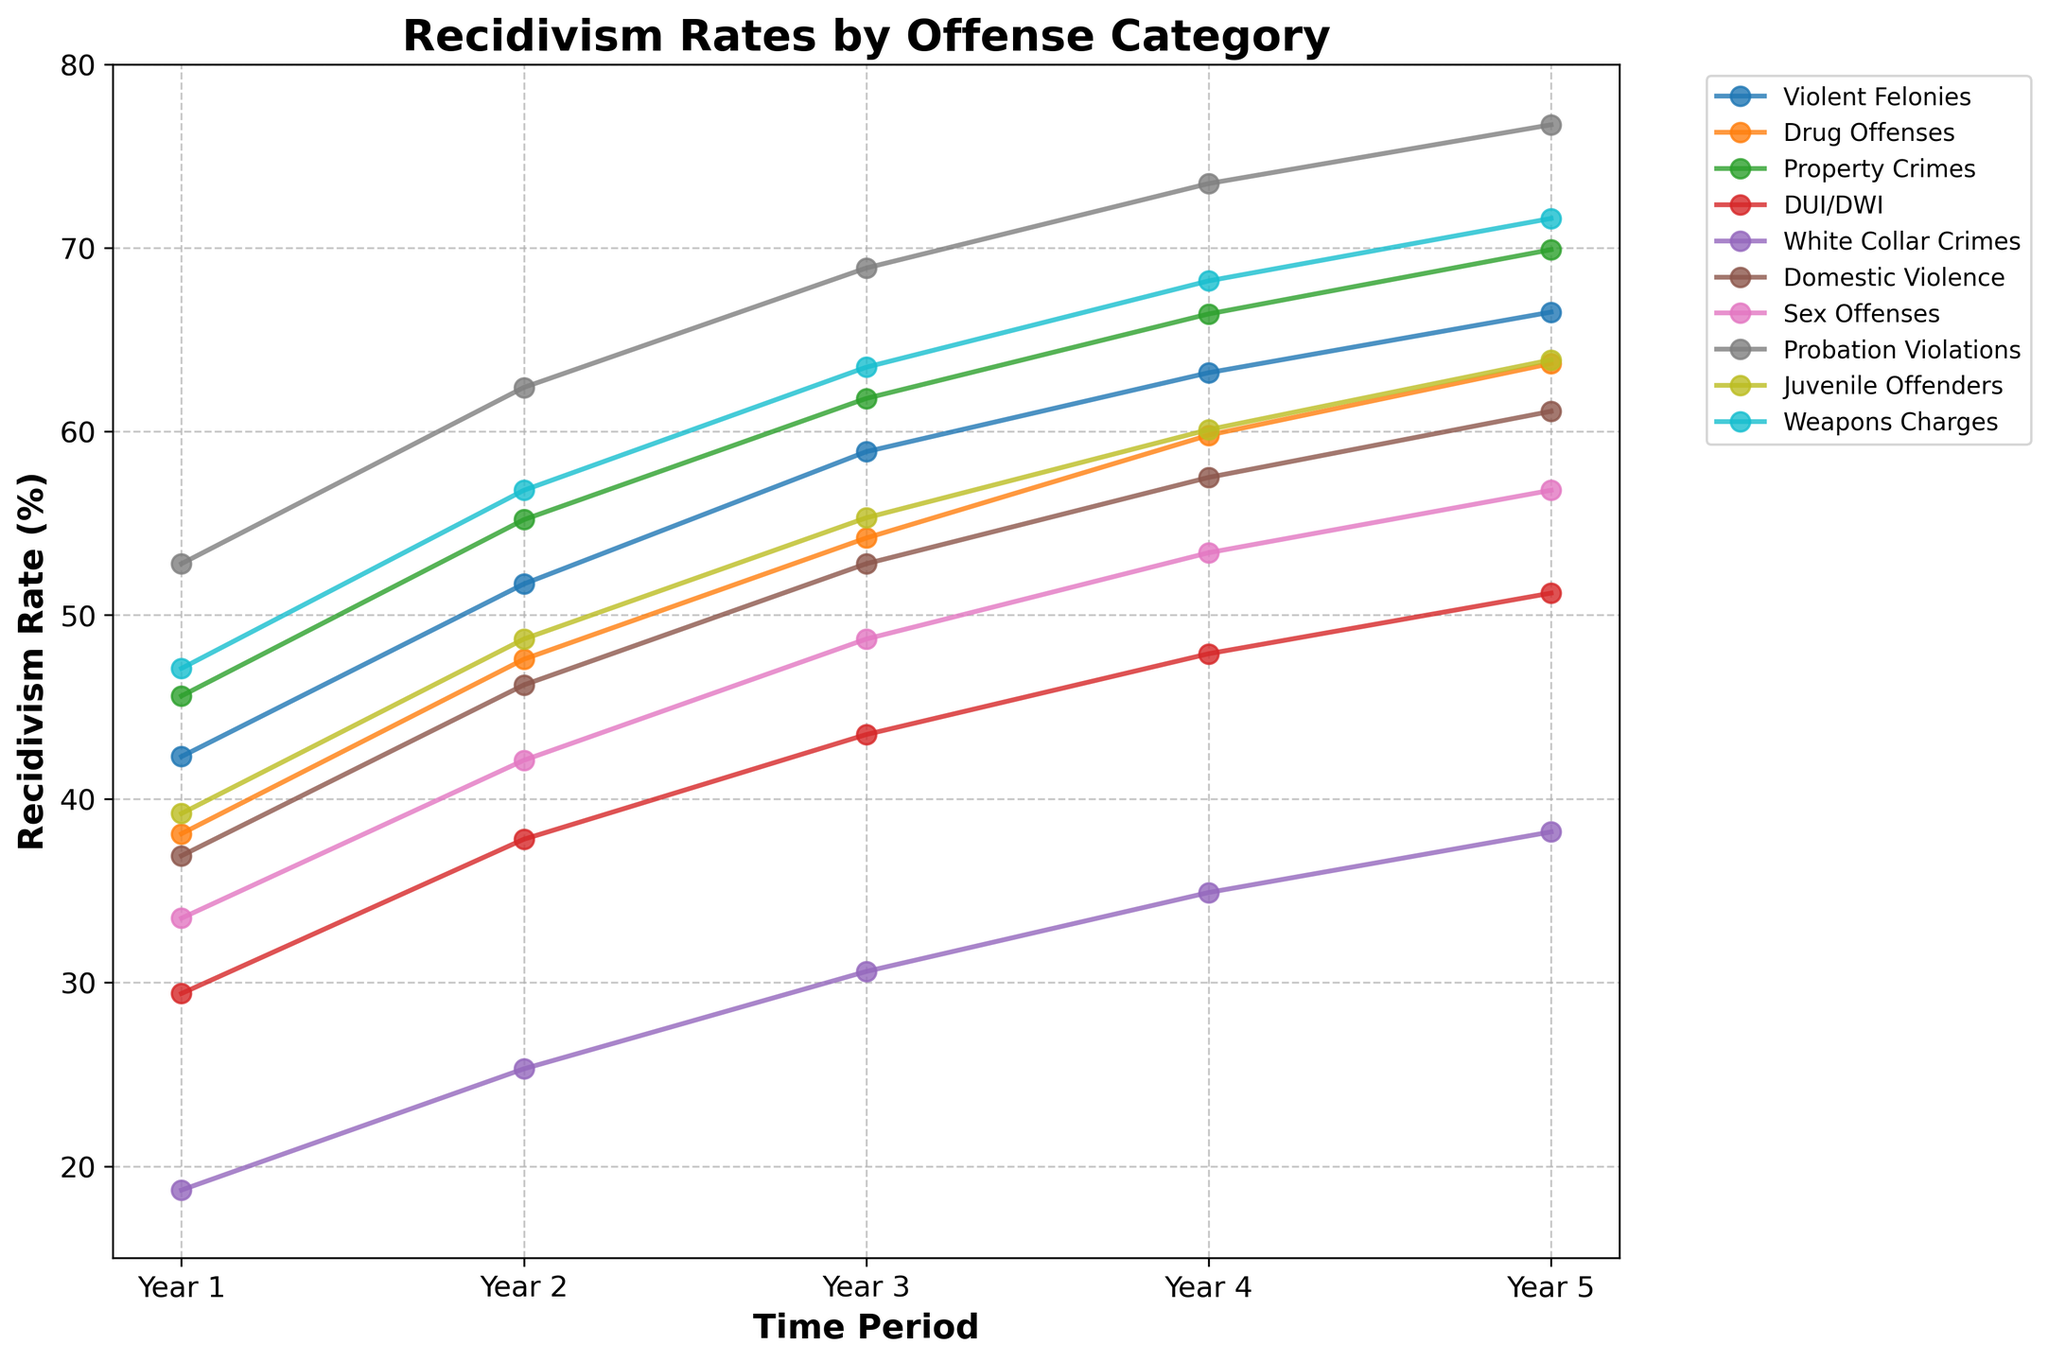What is the recidivism rate for DUI/DWI offenders in Year 3? Locate the line for DUI/DWI offenders and find the point corresponding to Year 3. The point's vertical position shows the rate.
Answer: 43.5 Which offender category has the highest recidivism rate in Year 5? Check the points for each category in Year 5 and identify the one with the highest position.
Answer: Probation Violations How much did the recidivism rate for Drug Offenses increase between Year 1 and Year 4? Subtract the Year 1 rate of Drug Offenses from the Year 4 rate. Calculation: 59.8 - 38.1.
Answer: 21.7 Which year shows the most significant increase in recidivism rate for Violent Felonies? Analyze the yearly differences in recidivism rates for Violent Felonies and identify the largest increase.
Answer: Year 2 to Year 3 What is the average recidivism rate of White Collar Crimes over the 5-year period? Sum the rates for White Collar Crimes across all years and divide by 5. Calculation: (18.7 + 25.3 + 30.6 + 34.9 + 38.2) / 5.
Answer: 29.54 Which offender category has the lowest recidivism rate in Year 1? Find the point with the lowest position for all categories in Year 1.
Answer: White Collar Crimes Compare the recidivism rates of Sex Offenses and Domestic Violence in Year 4. Which is higher? Locate the points for both categories in Year 4 and compare their vertical positions.
Answer: Domestic Violence What is the total increase in recidivism rate for Property Crimes over the 5-year period? Subtract the Year 1 rate of Property Crimes from the Year 5 rate. Calculation: 69.9 - 45.6.
Answer: 24.3 Which offender category shows the least increase in recidivism rate from Year 2 to Year 3? Calculate the increase for each category from Year 2 to Year 3 and find the smallest value.
Answer: White Collar Crimes How does the recidivism rate for Juvenile Offenders in Year 5 compare to that of Drug Offenses in Year 5? Compare the points for Juvenile Offenders and Drug Offenses in Year 5.
Answer: Lower 